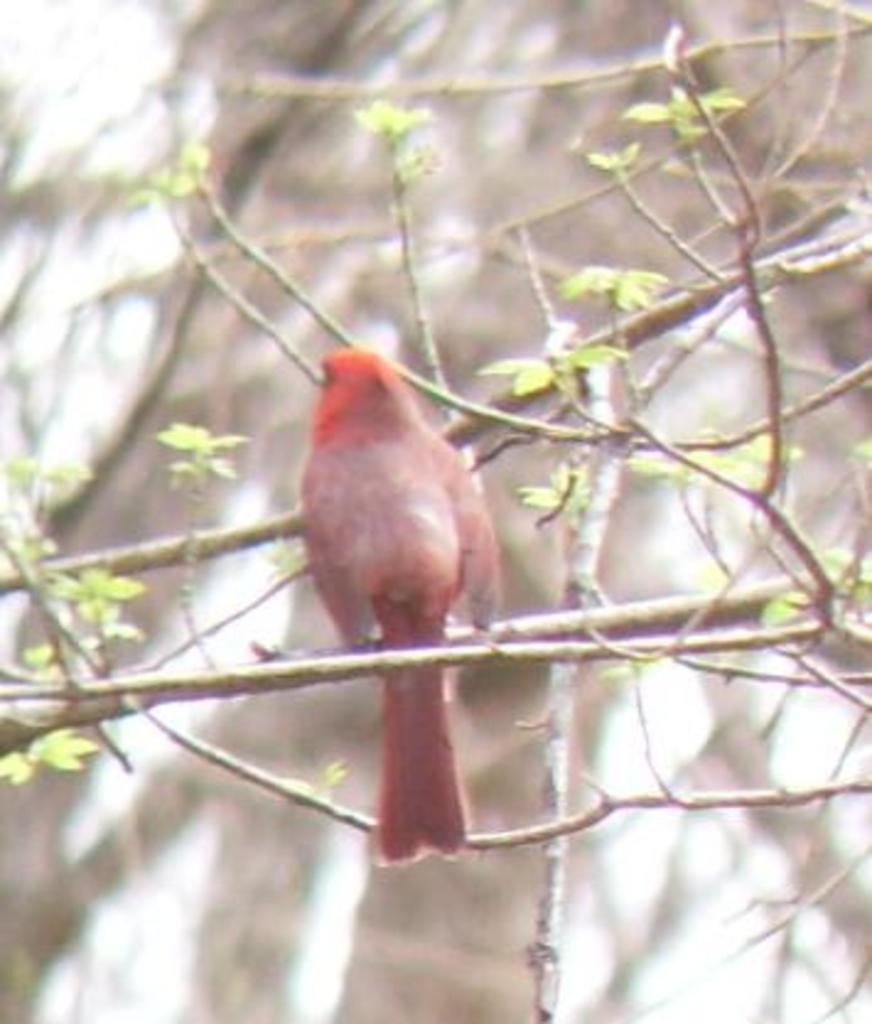What is the main subject in the middle of the image? There is a bird in the middle of the image. What can be seen on the right side of the image? There is a plant on the right side of the image. How would you describe the background of the image? The background of the image is blurry. How many visitors can be seen laughing in the image? There are no visitors or laughter present in the image; it features a bird and a plant. 